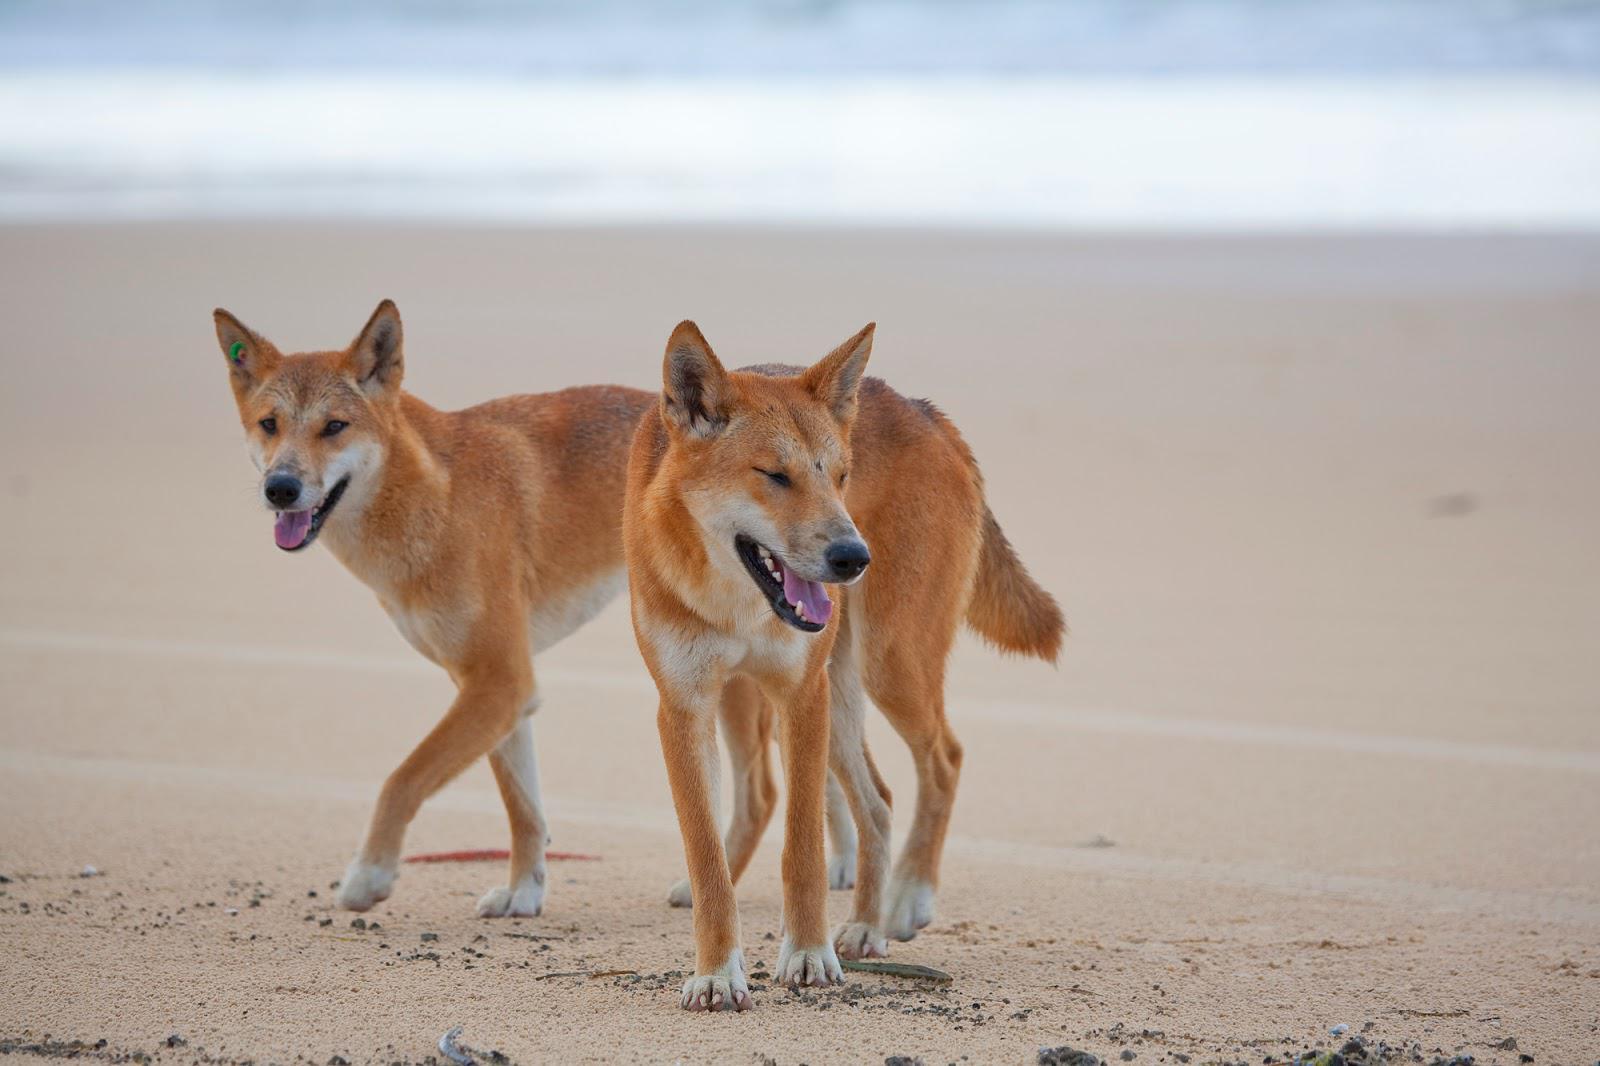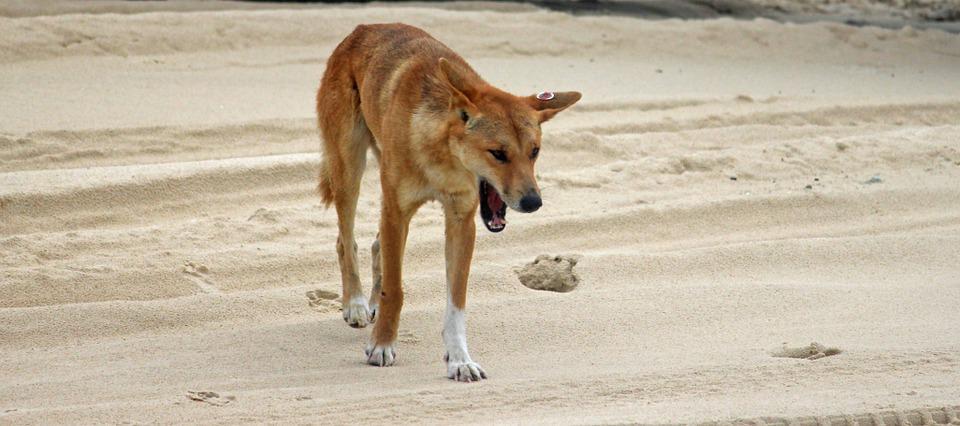The first image is the image on the left, the second image is the image on the right. Given the left and right images, does the statement "There is a dog dragging a snake over sand." hold true? Answer yes or no. No. 